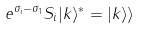<formula> <loc_0><loc_0><loc_500><loc_500>e ^ { \sigma _ { i } - \sigma _ { 1 } } S _ { i } | k \rangle ^ { * } = | k \rangle \rangle</formula> 